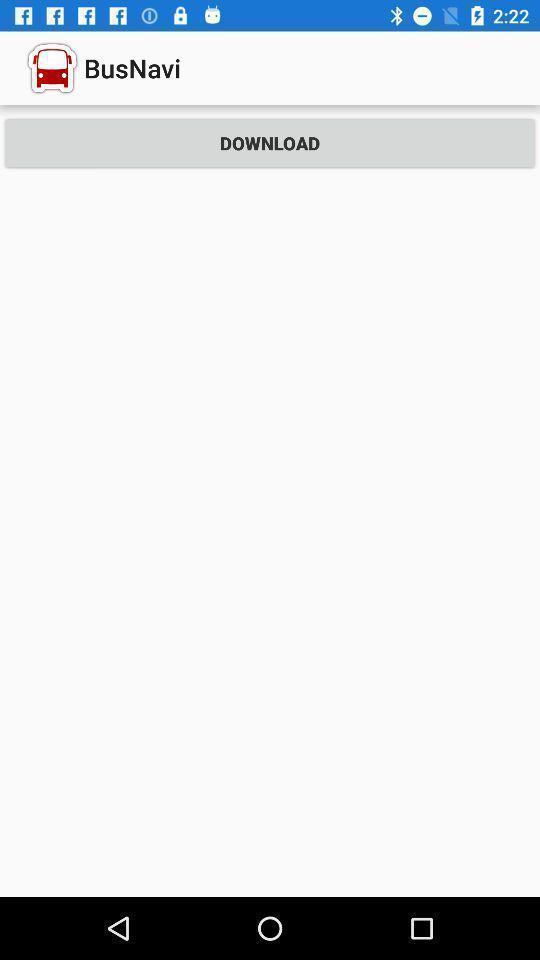Give me a summary of this screen capture. Screen showing to download a travel app. 